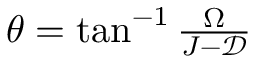<formula> <loc_0><loc_0><loc_500><loc_500>\begin{array} { r } { \theta = \tan ^ { - 1 } \frac { \Omega } { J - \mathcal { D } } } \end{array}</formula> 